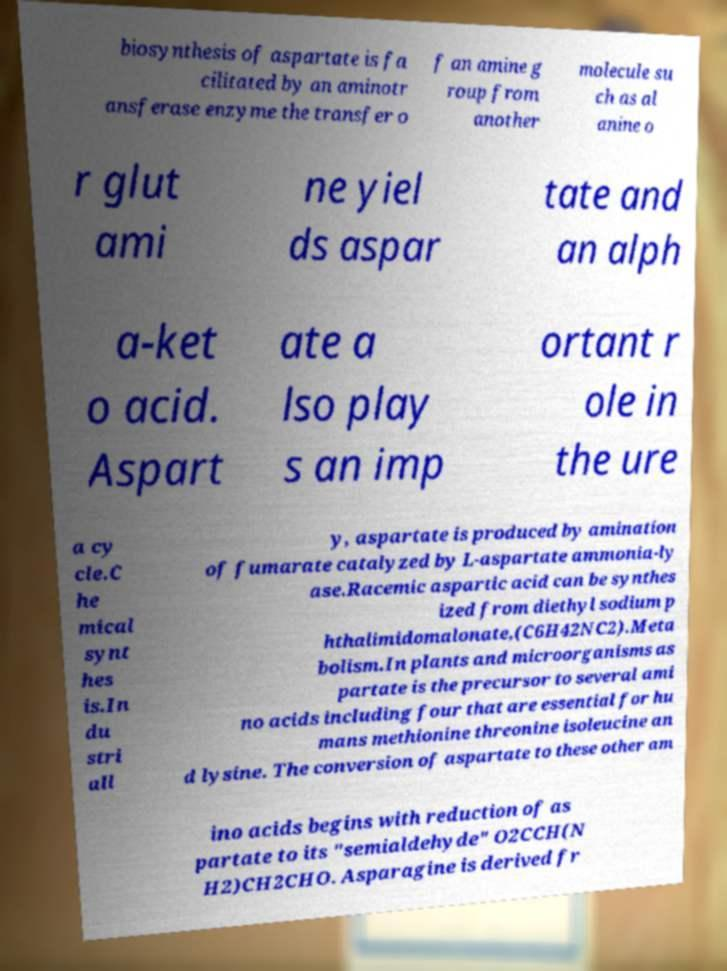Can you accurately transcribe the text from the provided image for me? biosynthesis of aspartate is fa cilitated by an aminotr ansferase enzyme the transfer o f an amine g roup from another molecule su ch as al anine o r glut ami ne yiel ds aspar tate and an alph a-ket o acid. Aspart ate a lso play s an imp ortant r ole in the ure a cy cle.C he mical synt hes is.In du stri all y, aspartate is produced by amination of fumarate catalyzed by L-aspartate ammonia-ly ase.Racemic aspartic acid can be synthes ized from diethyl sodium p hthalimidomalonate,(C6H42NC2).Meta bolism.In plants and microorganisms as partate is the precursor to several ami no acids including four that are essential for hu mans methionine threonine isoleucine an d lysine. The conversion of aspartate to these other am ino acids begins with reduction of as partate to its "semialdehyde" O2CCH(N H2)CH2CHO. Asparagine is derived fr 